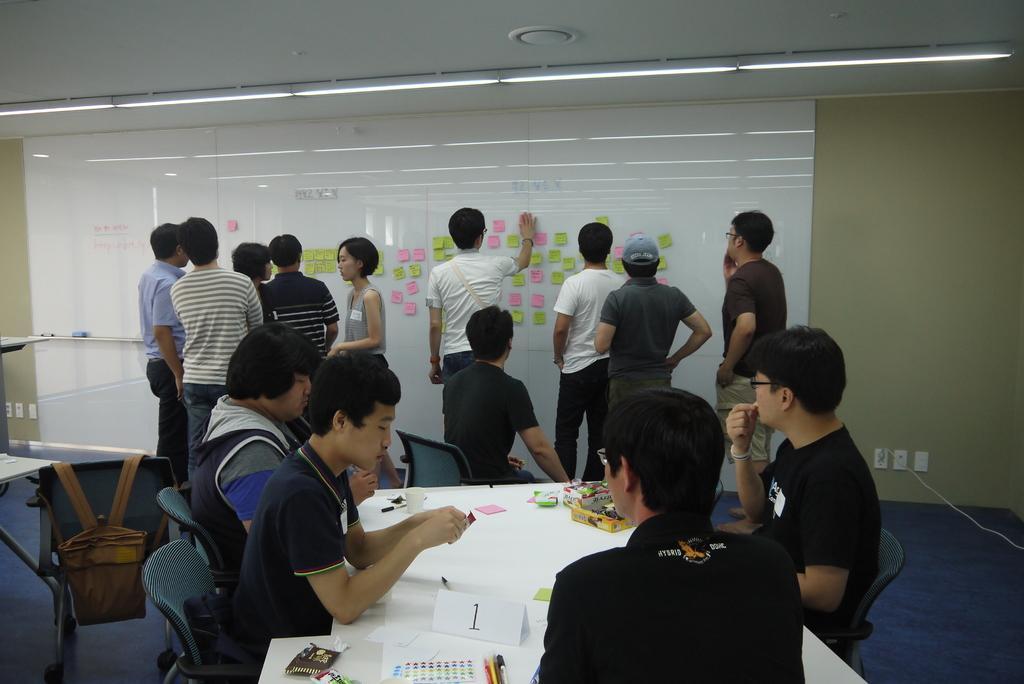Could you give a brief overview of what you see in this image? There are some people standing here, near a whiteboard to which some papers were stuck. There are some people sitting in the chairs in front of a table on which some papers and accessories were placed. In the background there is a wall. 